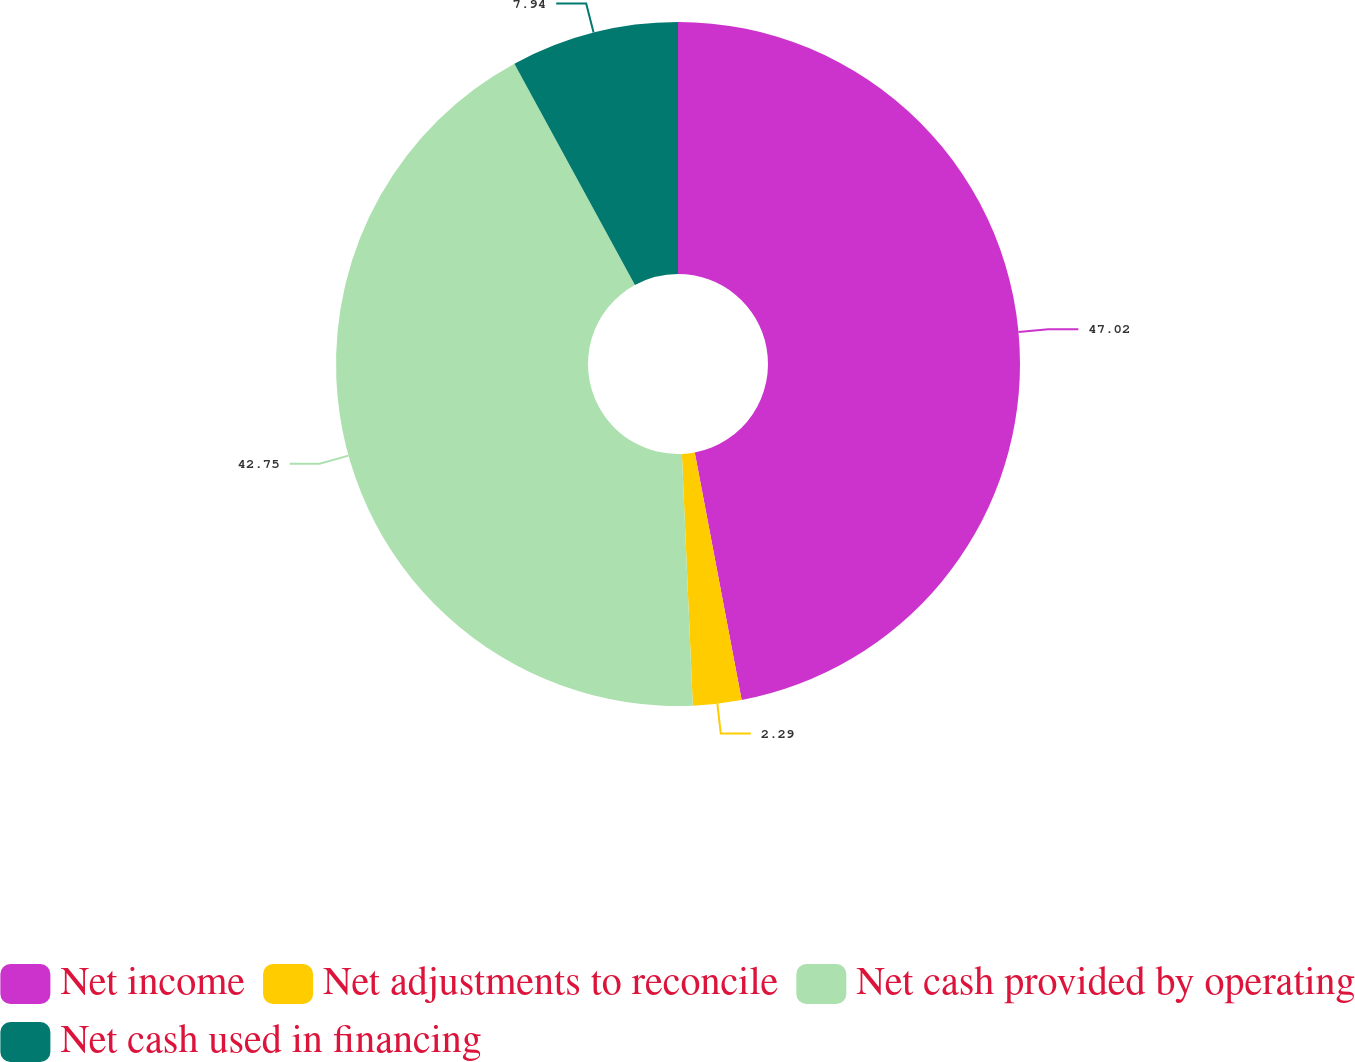Convert chart. <chart><loc_0><loc_0><loc_500><loc_500><pie_chart><fcel>Net income<fcel>Net adjustments to reconcile<fcel>Net cash provided by operating<fcel>Net cash used in financing<nl><fcel>47.02%<fcel>2.29%<fcel>42.75%<fcel>7.94%<nl></chart> 